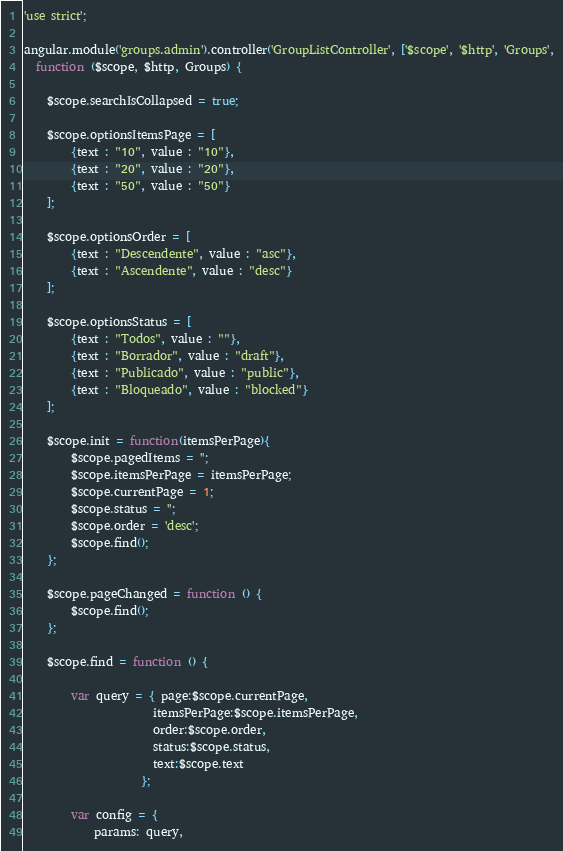<code> <loc_0><loc_0><loc_500><loc_500><_JavaScript_>'use strict';

angular.module('groups.admin').controller('GroupListController', ['$scope', '$http', 'Groups',
  function ($scope, $http, Groups) {
    
    $scope.searchIsCollapsed = true;
      
    $scope.optionsItemsPage = [
        {text : "10", value : "10"},
        {text : "20", value : "20"},
        {text : "50", value : "50"}
    ];
    
    $scope.optionsOrder = [
        {text : "Descendente", value : "asc"},
        {text : "Ascendente", value : "desc"}
    ];
    
    $scope.optionsStatus = [
        {text : "Todos", value : ""},
        {text : "Borrador", value : "draft"},
        {text : "Publicado", value : "public"},
        {text : "Bloqueado", value : "blocked"}
    ];
      
    $scope.init = function(itemsPerPage){
        $scope.pagedItems = '';
        $scope.itemsPerPage = itemsPerPage;
        $scope.currentPage = 1;
        $scope.status = '';
        $scope.order = 'desc';
        $scope.find();
    };
    
    $scope.pageChanged = function () {
        $scope.find();
    };
    
    $scope.find = function () {
        
        var query = { page:$scope.currentPage,
                      itemsPerPage:$scope.itemsPerPage,
                      order:$scope.order,
                      status:$scope.status,
                      text:$scope.text
                    };
                    
        var config = {
            params: query,</code> 